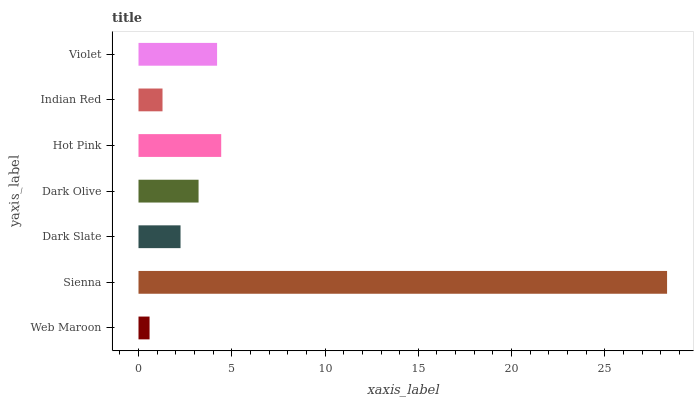Is Web Maroon the minimum?
Answer yes or no. Yes. Is Sienna the maximum?
Answer yes or no. Yes. Is Dark Slate the minimum?
Answer yes or no. No. Is Dark Slate the maximum?
Answer yes or no. No. Is Sienna greater than Dark Slate?
Answer yes or no. Yes. Is Dark Slate less than Sienna?
Answer yes or no. Yes. Is Dark Slate greater than Sienna?
Answer yes or no. No. Is Sienna less than Dark Slate?
Answer yes or no. No. Is Dark Olive the high median?
Answer yes or no. Yes. Is Dark Olive the low median?
Answer yes or no. Yes. Is Violet the high median?
Answer yes or no. No. Is Hot Pink the low median?
Answer yes or no. No. 